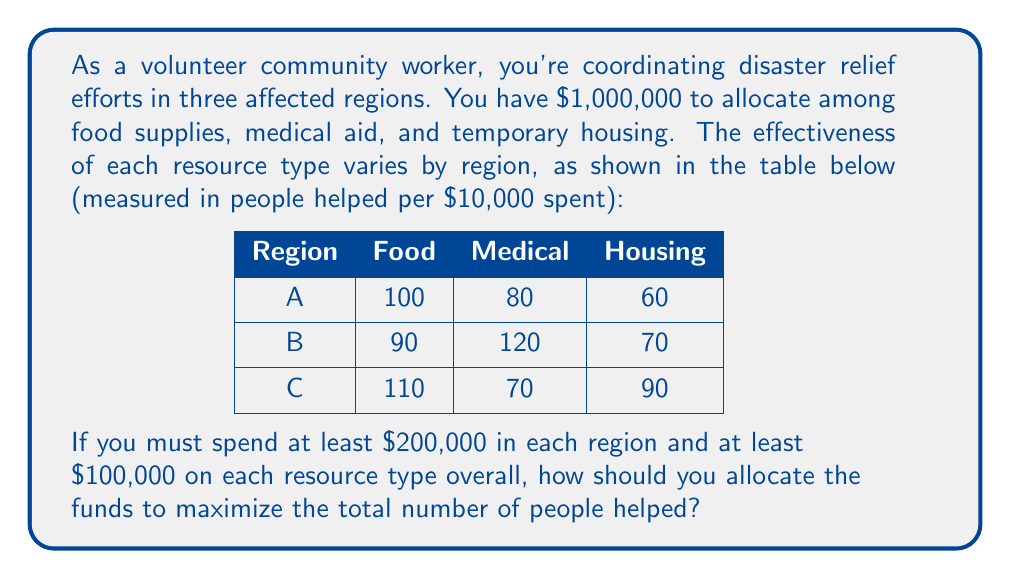Can you solve this math problem? This problem can be solved using linear programming. Let's define our variables:

$x_{ij}$ = amount (in $10,000 units) allocated to region $i$ for resource $j$

where $i \in \{A,B,C\}$ and $j \in \{F,M,H\}$ (Food, Medical, Housing)

Objective function (maximize):
$$100x_{AF} + 80x_{AM} + 60x_{AH} + 90x_{BF} + 120x_{BM} + 70x_{BH} + 110x_{CF} + 70x_{CM} + 90x_{CH}$$

Constraints:
1. Total budget: $\sum_{i,j} x_{ij} = 100$ (as we're working in $10,000 units)
2. Minimum spend per region:
   $x_{AF} + x_{AM} + x_{AH} \ge 20$
   $x_{BF} + x_{BM} + x_{BH} \ge 20$
   $x_{CF} + x_{CM} + x_{CH} \ge 20$
3. Minimum spend per resource type:
   $x_{AF} + x_{BF} + x_{CF} \ge 10$
   $x_{AM} + x_{BM} + x_{CM} \ge 10$
   $x_{AH} + x_{BH} + x_{CH} \ge 10$
4. Non-negativity: $x_{ij} \ge 0$ for all $i,j$

This linear programming problem can be solved using software like MATLAB, Python (with PuLP or SciPy), or specialized LP solvers. The optimal solution is:

$x_{AF} = 20, x_{AM} = 0, x_{AH} = 0$
$x_{BF} = 0, x_{BM} = 33.33, x_{BH} = 0$
$x_{CF} = 13.33, x_{CM} = 0, x_{CH} = 33.33$

This allocation maximizes the number of people helped.
Answer: The optimal allocation is:
Region A: $200,000 on food
Region B: $333,333 on medical aid
Region C: $133,333 on food, $333,333 on housing

This allocation helps a total of 41,333 people. 